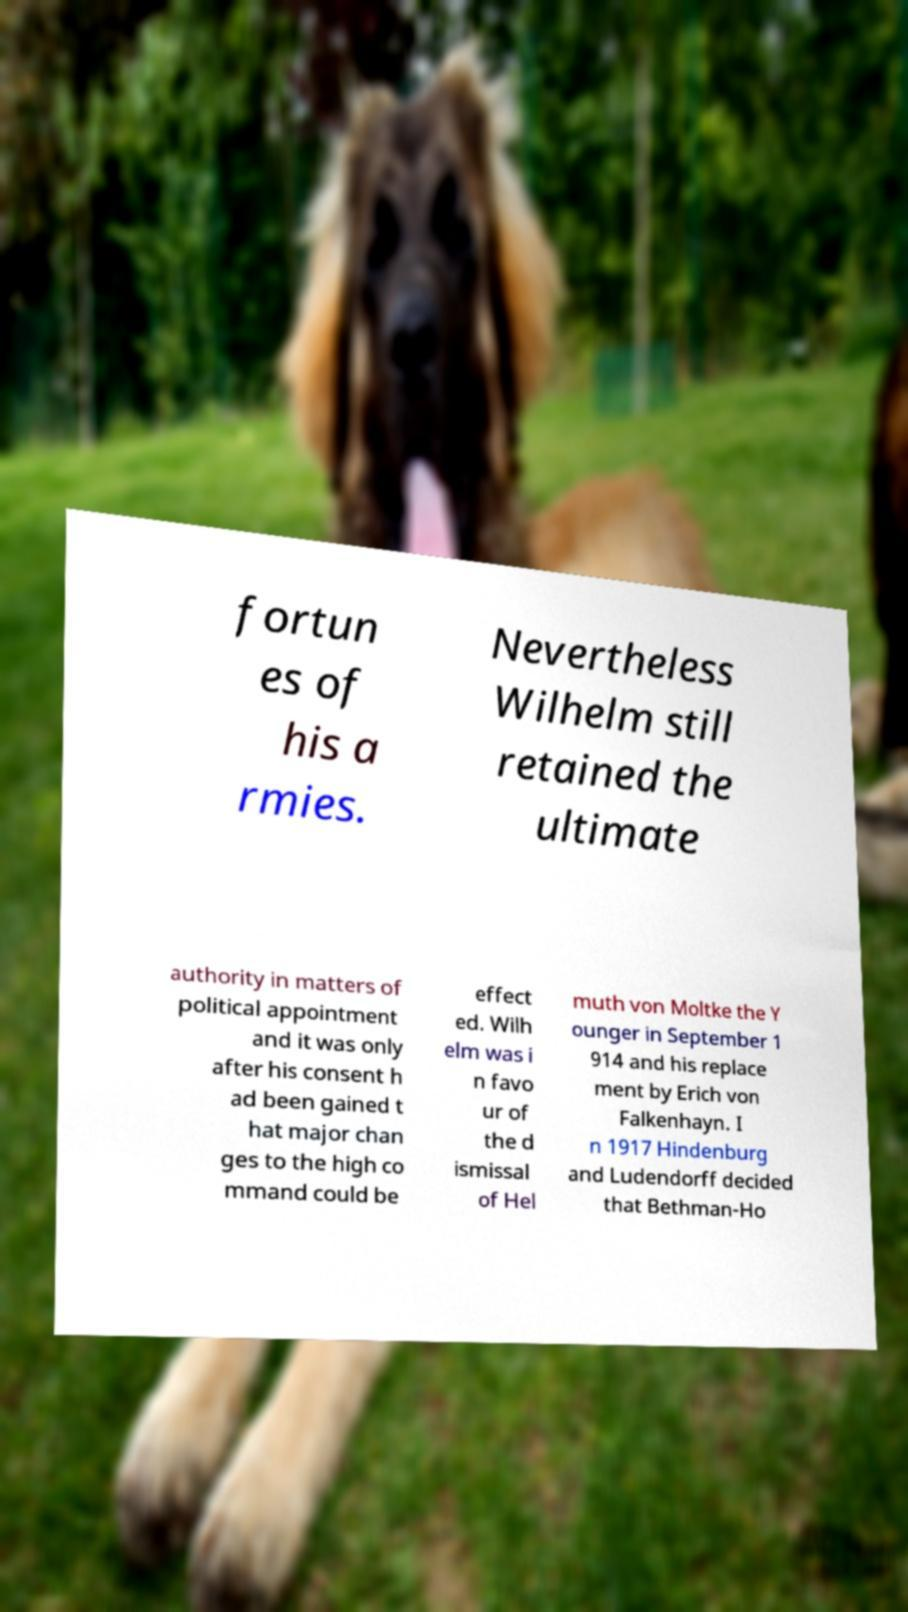For documentation purposes, I need the text within this image transcribed. Could you provide that? fortun es of his a rmies. Nevertheless Wilhelm still retained the ultimate authority in matters of political appointment and it was only after his consent h ad been gained t hat major chan ges to the high co mmand could be effect ed. Wilh elm was i n favo ur of the d ismissal of Hel muth von Moltke the Y ounger in September 1 914 and his replace ment by Erich von Falkenhayn. I n 1917 Hindenburg and Ludendorff decided that Bethman-Ho 